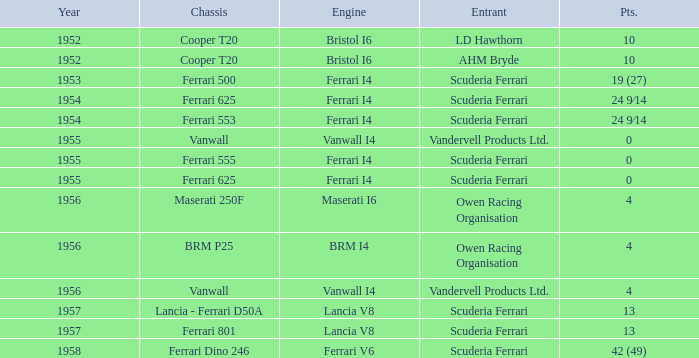Which entrant has 4 points and BRM p25 for the Chassis? Owen Racing Organisation. 